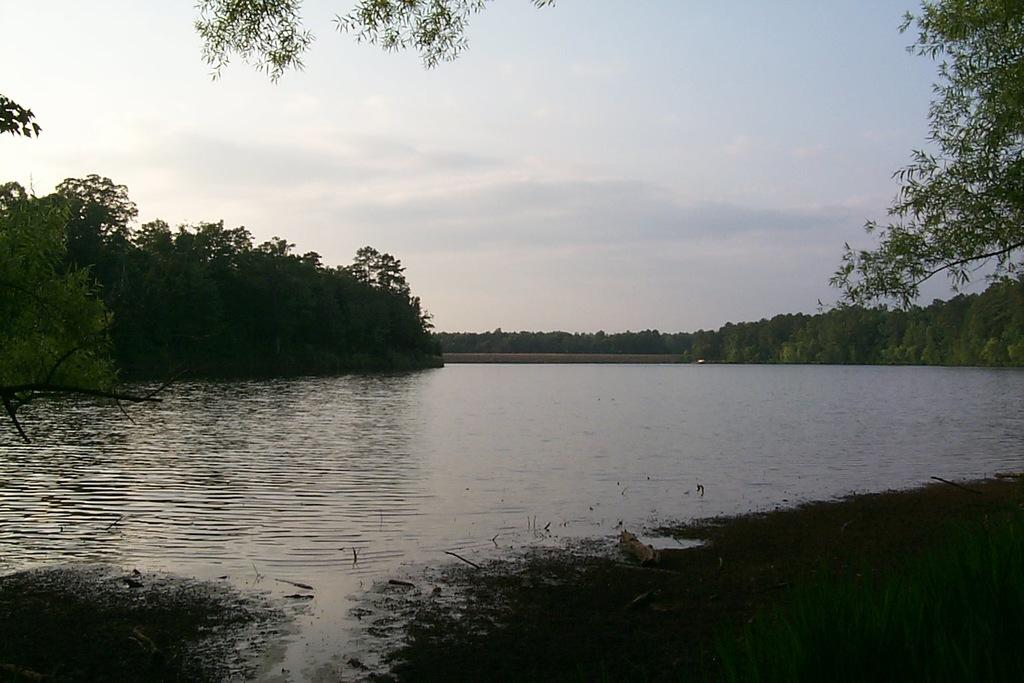What is the main feature in the center of the image? There is a river in the center of the image. What can be seen near the river? There are plants near the river. What type of vegetation is visible in the background of the image? There are trees in the background of the image. What is visible at the top of the image? The sky is visible at the top of the image. What type of needle can be seen floating in the river in the image? There is no needle present in the image; it only features a river, plants, trees, and the sky. 